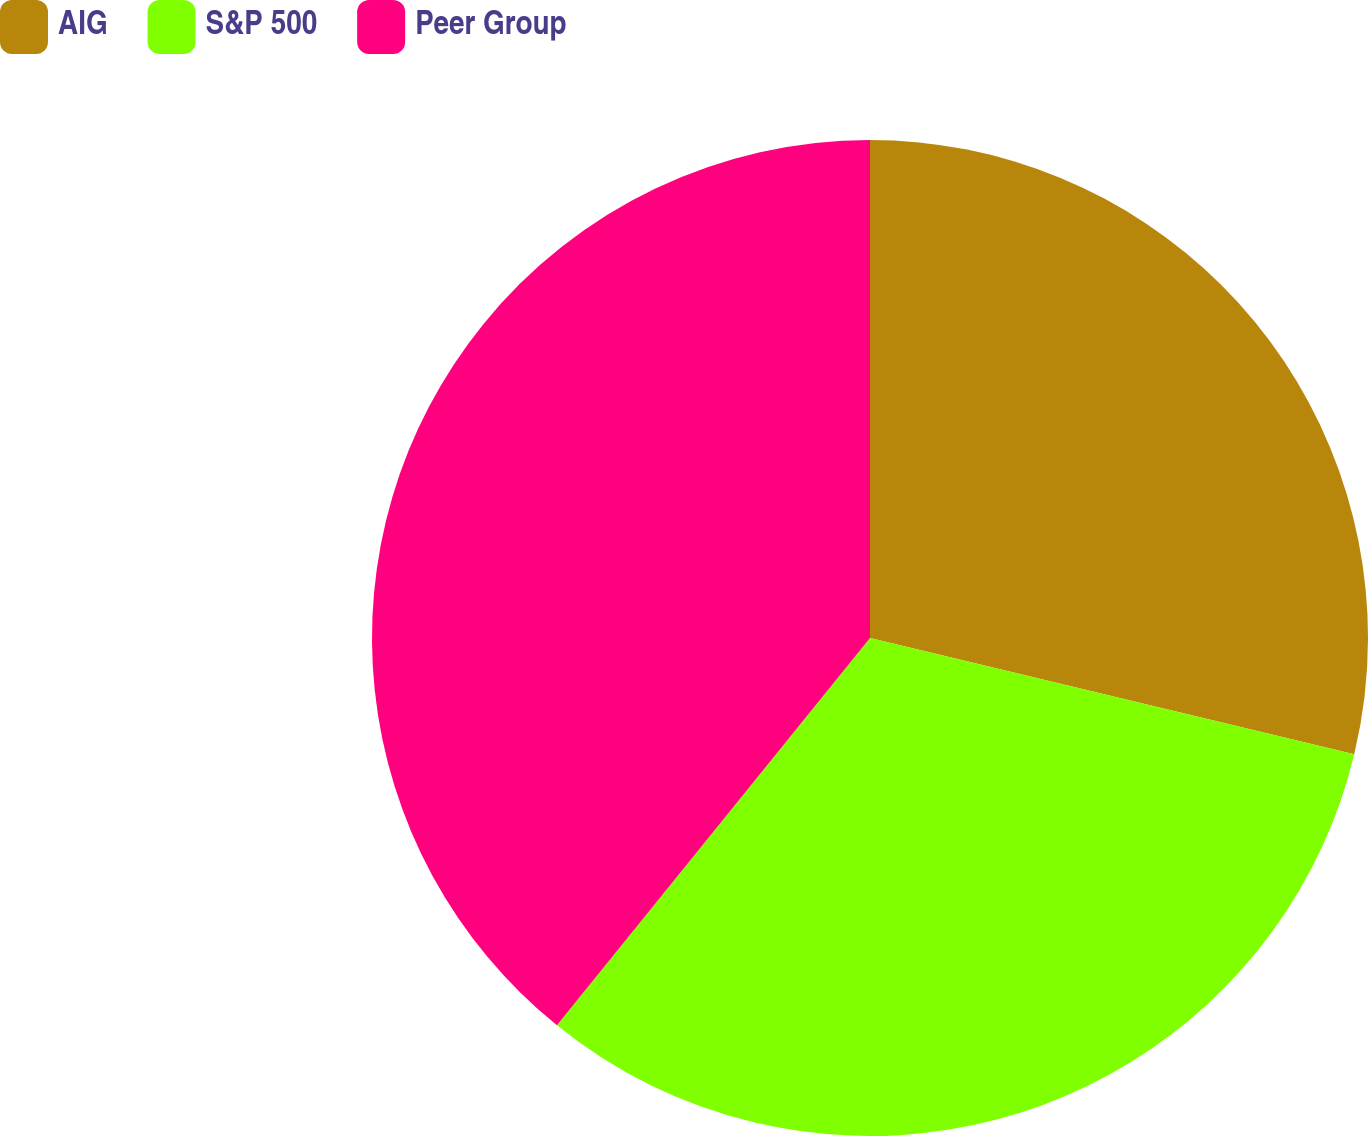Convert chart to OTSL. <chart><loc_0><loc_0><loc_500><loc_500><pie_chart><fcel>AIG<fcel>S&P 500<fcel>Peer Group<nl><fcel>28.75%<fcel>32.07%<fcel>39.18%<nl></chart> 